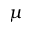Convert formula to latex. <formula><loc_0><loc_0><loc_500><loc_500>\mu</formula> 